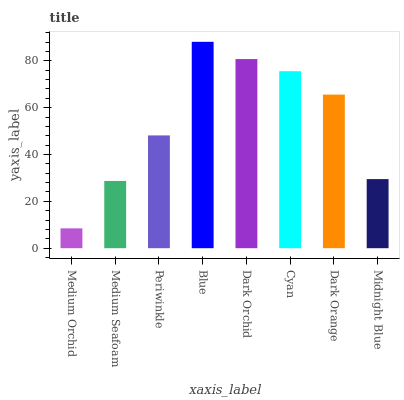Is Medium Orchid the minimum?
Answer yes or no. Yes. Is Blue the maximum?
Answer yes or no. Yes. Is Medium Seafoam the minimum?
Answer yes or no. No. Is Medium Seafoam the maximum?
Answer yes or no. No. Is Medium Seafoam greater than Medium Orchid?
Answer yes or no. Yes. Is Medium Orchid less than Medium Seafoam?
Answer yes or no. Yes. Is Medium Orchid greater than Medium Seafoam?
Answer yes or no. No. Is Medium Seafoam less than Medium Orchid?
Answer yes or no. No. Is Dark Orange the high median?
Answer yes or no. Yes. Is Periwinkle the low median?
Answer yes or no. Yes. Is Dark Orchid the high median?
Answer yes or no. No. Is Dark Orange the low median?
Answer yes or no. No. 